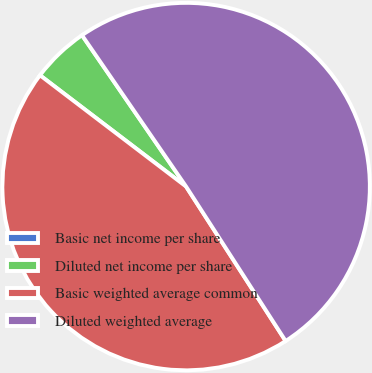Convert chart to OTSL. <chart><loc_0><loc_0><loc_500><loc_500><pie_chart><fcel>Basic net income per share<fcel>Diluted net income per share<fcel>Basic weighted average common<fcel>Diluted weighted average<nl><fcel>0.0%<fcel>5.05%<fcel>44.47%<fcel>50.48%<nl></chart> 